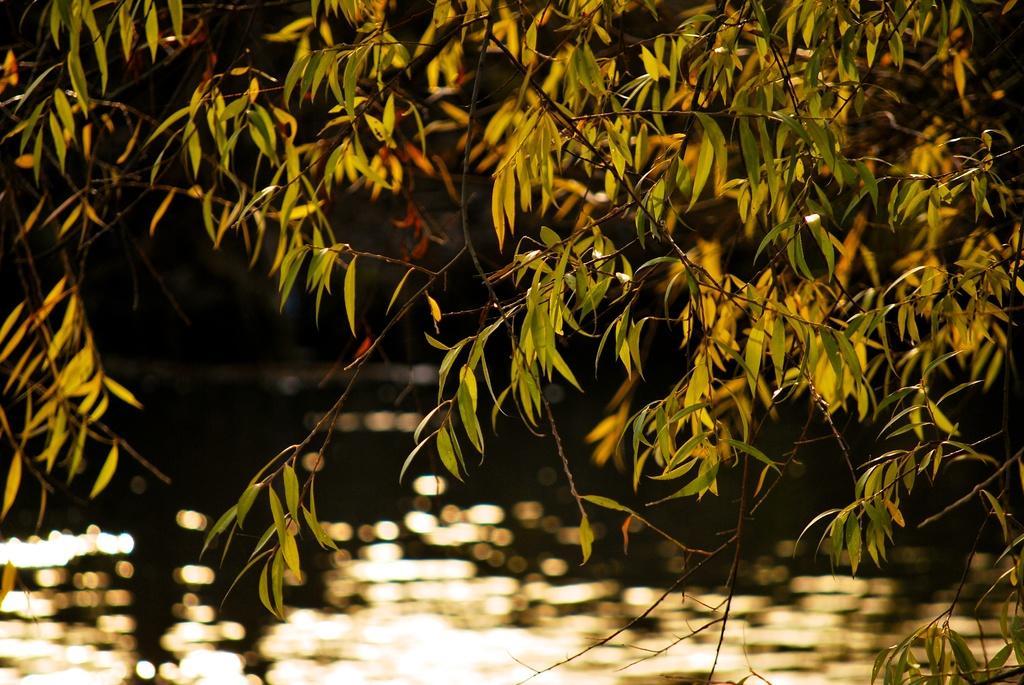Can you describe this image briefly? In this image, we can see green leaves and there is water. 